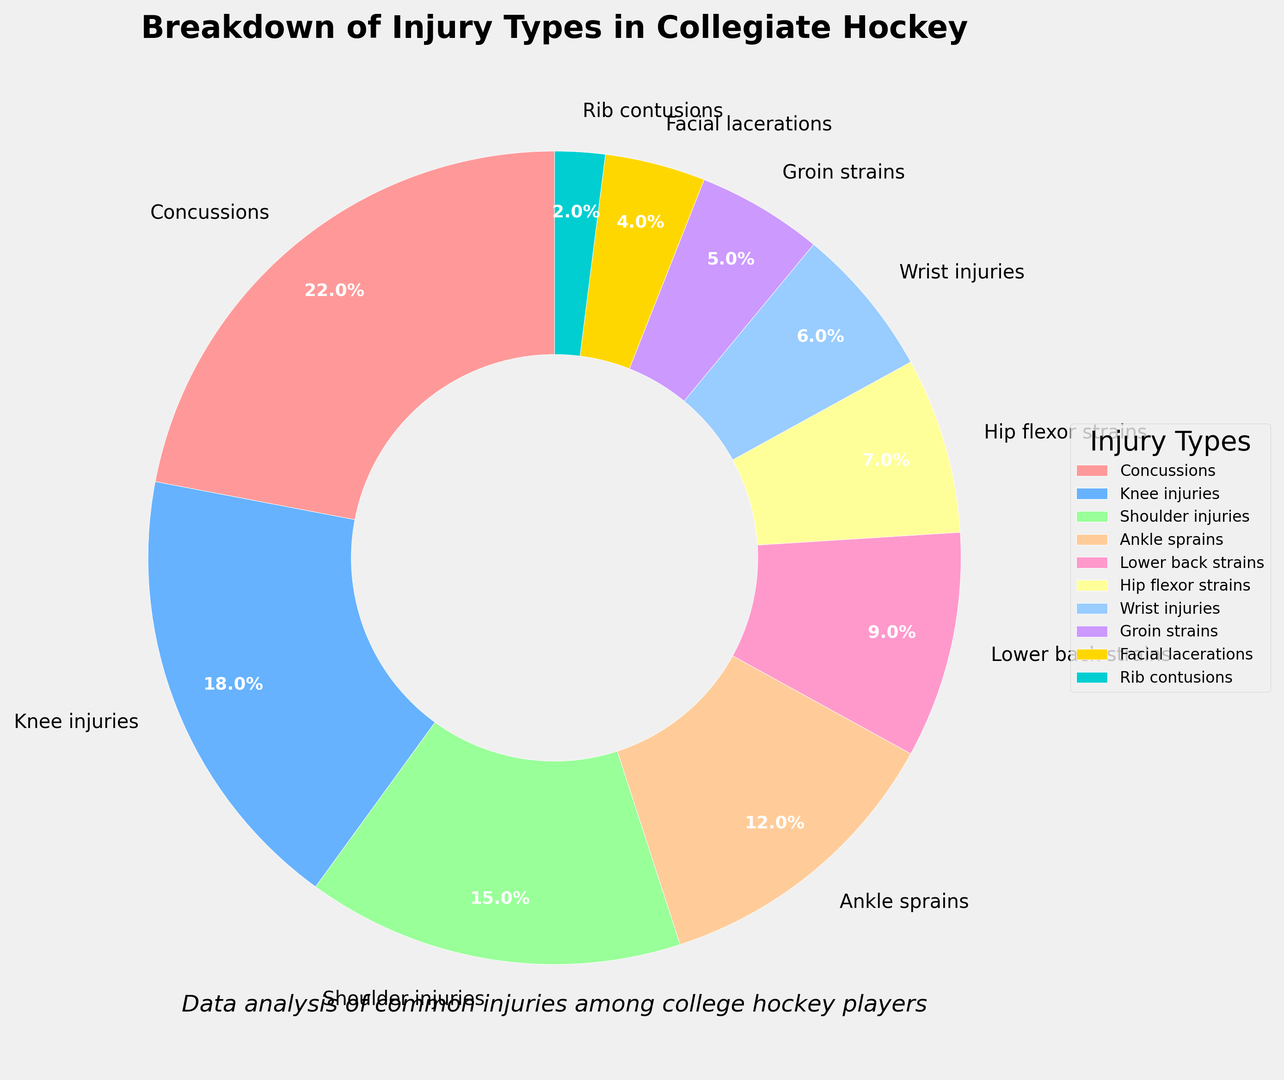Which injury type is most common among collegiate hockey players? The most common injury type is the one with the highest percentage in the pie chart. Concussions are listed with 22%, which is the highest value among all injury types.
Answer: Concussions Which injury type is least common among collegiate hockey players? The least common injury type is the one with the lowest percentage in the pie chart. Rib contusions are listed with 2%, which is the lowest value among all injury types.
Answer: Rib contusions How do the percentages of knee injuries and shoulder injuries compare? By referring to the pie chart, knee injuries have a percentage of 18%, while shoulder injuries have 15%. Comparing these values shows that knee injuries are 3% more common than shoulder injuries.
Answer: Knee injuries are more common What is the combined percentage of ankle sprains and lower back strains? The percentage of ankle sprains is 12% and lower back strains is 9%. Adding these together gives 12% + 9% = 21%.
Answer: 21% What percentage of injuries are related to either the hips or groin? The percentage of hip flexor strains is 7% and groin strains is 5%. Adding these together gives 7% + 5% = 12%.
Answer: 12% Compare the frequency of facial lacerations and wrist injuries. Which one is more common? The pie chart shows facial lacerations at 4% and wrist injuries at 6%. Comparing these values indicates that wrist injuries are more common than facial lacerations.
Answer: Wrist injuries What is the sum of the percentages for concussion, knee injuries, and shoulder injuries? Concussions account for 22%, knee injuries 18%, and shoulder injuries 15%. Summing these values gives 22% + 18% + 15% = 55%.
Answer: 55% Which injury types combined make up less than 10%? To find injury types that together sum to less than 10%, we look for those with small percentages. Rib contusions (2%) are the only ones below 10% by themselves. The next smallest addition would be facial lacerations (4%), but the total would still be less than 10%. Adding one more, groin strains (5%) ups the total to 11%, thus not fitting the criteria. Rib contusions and facial lacerations together do meet the criteria.
Answer: Rib contusions and facial lacerations 